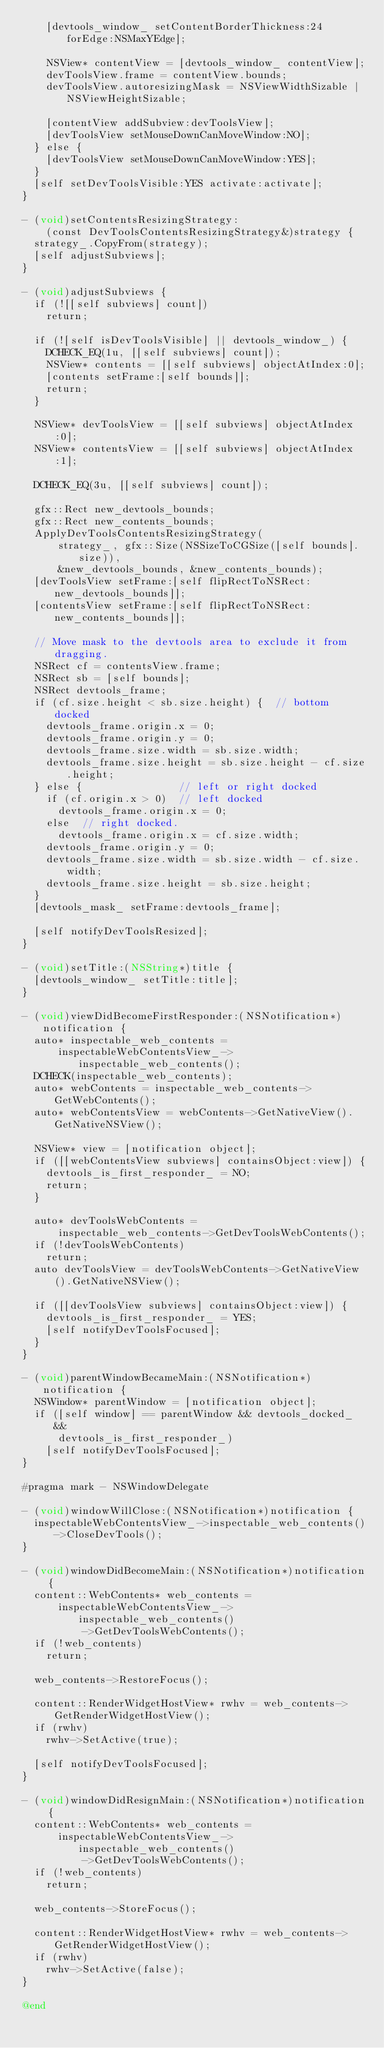Convert code to text. <code><loc_0><loc_0><loc_500><loc_500><_ObjectiveC_>    [devtools_window_ setContentBorderThickness:24 forEdge:NSMaxYEdge];

    NSView* contentView = [devtools_window_ contentView];
    devToolsView.frame = contentView.bounds;
    devToolsView.autoresizingMask = NSViewWidthSizable | NSViewHeightSizable;

    [contentView addSubview:devToolsView];
    [devToolsView setMouseDownCanMoveWindow:NO];
  } else {
    [devToolsView setMouseDownCanMoveWindow:YES];
  }
  [self setDevToolsVisible:YES activate:activate];
}

- (void)setContentsResizingStrategy:
    (const DevToolsContentsResizingStrategy&)strategy {
  strategy_.CopyFrom(strategy);
  [self adjustSubviews];
}

- (void)adjustSubviews {
  if (![[self subviews] count])
    return;

  if (![self isDevToolsVisible] || devtools_window_) {
    DCHECK_EQ(1u, [[self subviews] count]);
    NSView* contents = [[self subviews] objectAtIndex:0];
    [contents setFrame:[self bounds]];
    return;
  }

  NSView* devToolsView = [[self subviews] objectAtIndex:0];
  NSView* contentsView = [[self subviews] objectAtIndex:1];

  DCHECK_EQ(3u, [[self subviews] count]);

  gfx::Rect new_devtools_bounds;
  gfx::Rect new_contents_bounds;
  ApplyDevToolsContentsResizingStrategy(
      strategy_, gfx::Size(NSSizeToCGSize([self bounds].size)),
      &new_devtools_bounds, &new_contents_bounds);
  [devToolsView setFrame:[self flipRectToNSRect:new_devtools_bounds]];
  [contentsView setFrame:[self flipRectToNSRect:new_contents_bounds]];

  // Move mask to the devtools area to exclude it from dragging.
  NSRect cf = contentsView.frame;
  NSRect sb = [self bounds];
  NSRect devtools_frame;
  if (cf.size.height < sb.size.height) {  // bottom docked
    devtools_frame.origin.x = 0;
    devtools_frame.origin.y = 0;
    devtools_frame.size.width = sb.size.width;
    devtools_frame.size.height = sb.size.height - cf.size.height;
  } else {                // left or right docked
    if (cf.origin.x > 0)  // left docked
      devtools_frame.origin.x = 0;
    else  // right docked.
      devtools_frame.origin.x = cf.size.width;
    devtools_frame.origin.y = 0;
    devtools_frame.size.width = sb.size.width - cf.size.width;
    devtools_frame.size.height = sb.size.height;
  }
  [devtools_mask_ setFrame:devtools_frame];

  [self notifyDevToolsResized];
}

- (void)setTitle:(NSString*)title {
  [devtools_window_ setTitle:title];
}

- (void)viewDidBecomeFirstResponder:(NSNotification*)notification {
  auto* inspectable_web_contents =
      inspectableWebContentsView_->inspectable_web_contents();
  DCHECK(inspectable_web_contents);
  auto* webContents = inspectable_web_contents->GetWebContents();
  auto* webContentsView = webContents->GetNativeView().GetNativeNSView();

  NSView* view = [notification object];
  if ([[webContentsView subviews] containsObject:view]) {
    devtools_is_first_responder_ = NO;
    return;
  }

  auto* devToolsWebContents =
      inspectable_web_contents->GetDevToolsWebContents();
  if (!devToolsWebContents)
    return;
  auto devToolsView = devToolsWebContents->GetNativeView().GetNativeNSView();

  if ([[devToolsView subviews] containsObject:view]) {
    devtools_is_first_responder_ = YES;
    [self notifyDevToolsFocused];
  }
}

- (void)parentWindowBecameMain:(NSNotification*)notification {
  NSWindow* parentWindow = [notification object];
  if ([self window] == parentWindow && devtools_docked_ &&
      devtools_is_first_responder_)
    [self notifyDevToolsFocused];
}

#pragma mark - NSWindowDelegate

- (void)windowWillClose:(NSNotification*)notification {
  inspectableWebContentsView_->inspectable_web_contents()->CloseDevTools();
}

- (void)windowDidBecomeMain:(NSNotification*)notification {
  content::WebContents* web_contents =
      inspectableWebContentsView_->inspectable_web_contents()
          ->GetDevToolsWebContents();
  if (!web_contents)
    return;

  web_contents->RestoreFocus();

  content::RenderWidgetHostView* rwhv = web_contents->GetRenderWidgetHostView();
  if (rwhv)
    rwhv->SetActive(true);

  [self notifyDevToolsFocused];
}

- (void)windowDidResignMain:(NSNotification*)notification {
  content::WebContents* web_contents =
      inspectableWebContentsView_->inspectable_web_contents()
          ->GetDevToolsWebContents();
  if (!web_contents)
    return;

  web_contents->StoreFocus();

  content::RenderWidgetHostView* rwhv = web_contents->GetRenderWidgetHostView();
  if (rwhv)
    rwhv->SetActive(false);
}

@end
</code> 